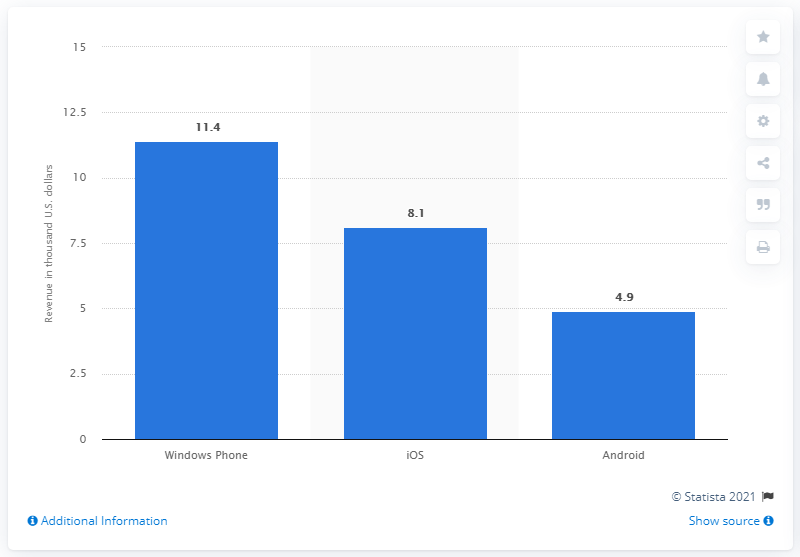Specify some key components in this picture. Windows Phone is the most popular operating system among app developers. 